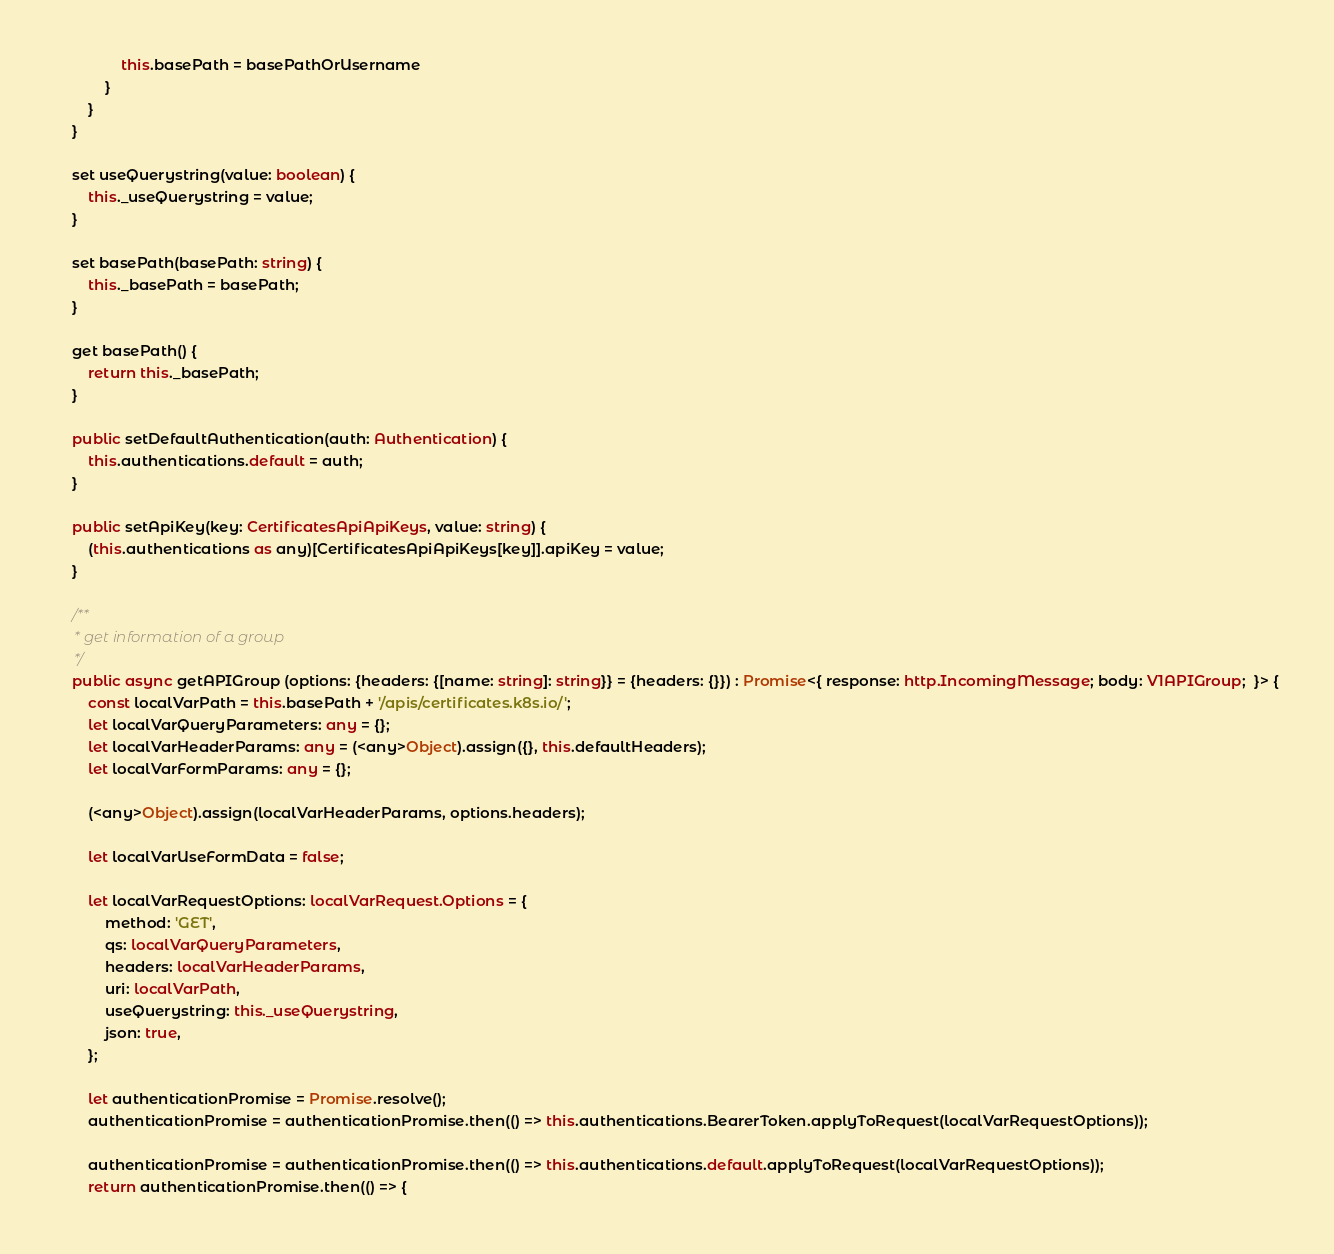Convert code to text. <code><loc_0><loc_0><loc_500><loc_500><_TypeScript_>                this.basePath = basePathOrUsername
            }
        }
    }

    set useQuerystring(value: boolean) {
        this._useQuerystring = value;
    }

    set basePath(basePath: string) {
        this._basePath = basePath;
    }

    get basePath() {
        return this._basePath;
    }

    public setDefaultAuthentication(auth: Authentication) {
        this.authentications.default = auth;
    }

    public setApiKey(key: CertificatesApiApiKeys, value: string) {
        (this.authentications as any)[CertificatesApiApiKeys[key]].apiKey = value;
    }

    /**
     * get information of a group
     */
    public async getAPIGroup (options: {headers: {[name: string]: string}} = {headers: {}}) : Promise<{ response: http.IncomingMessage; body: V1APIGroup;  }> {
        const localVarPath = this.basePath + '/apis/certificates.k8s.io/';
        let localVarQueryParameters: any = {};
        let localVarHeaderParams: any = (<any>Object).assign({}, this.defaultHeaders);
        let localVarFormParams: any = {};

        (<any>Object).assign(localVarHeaderParams, options.headers);

        let localVarUseFormData = false;

        let localVarRequestOptions: localVarRequest.Options = {
            method: 'GET',
            qs: localVarQueryParameters,
            headers: localVarHeaderParams,
            uri: localVarPath,
            useQuerystring: this._useQuerystring,
            json: true,
        };

        let authenticationPromise = Promise.resolve();
        authenticationPromise = authenticationPromise.then(() => this.authentications.BearerToken.applyToRequest(localVarRequestOptions));

        authenticationPromise = authenticationPromise.then(() => this.authentications.default.applyToRequest(localVarRequestOptions));
        return authenticationPromise.then(() => {</code> 